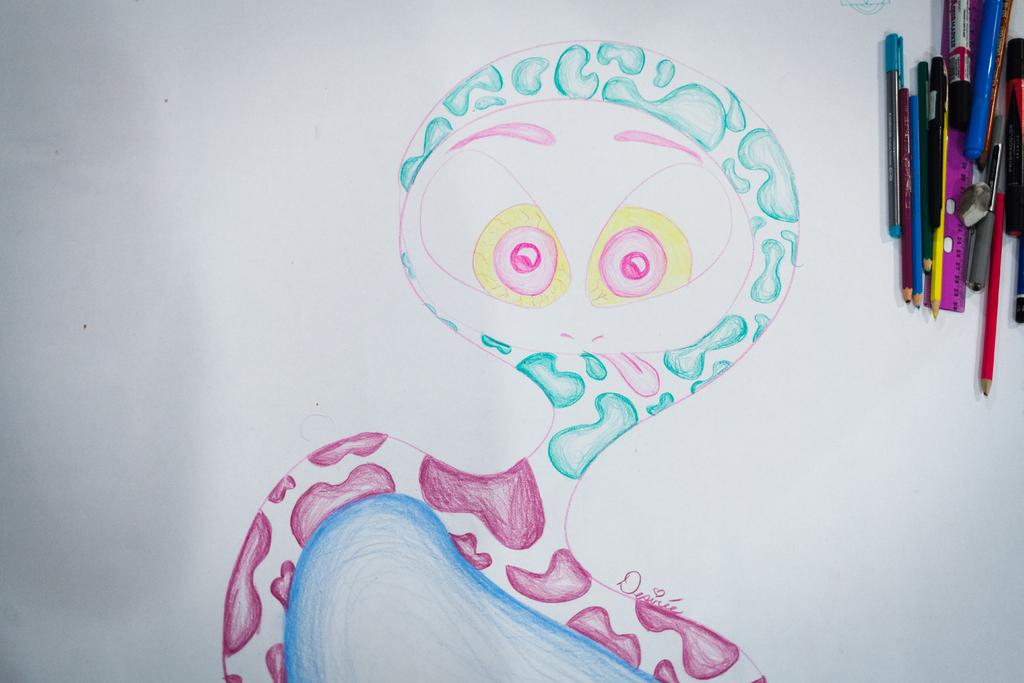What is depicted on the white color sheet in the image? There is a drawing on a white color sheet in the image. What can be observed about the drawing in terms of color? The drawing uses different colors. Where are the color pencils located in the image? The color pencils are in the right top corner of the image. What other items can be seen in the right top corner? There is a pink color scale, a pen, and a sketch in the right top corner. What type of feather is used as a decoration in the drawing? There are no feathers present in the image, and the drawing does not depict any decorations. 